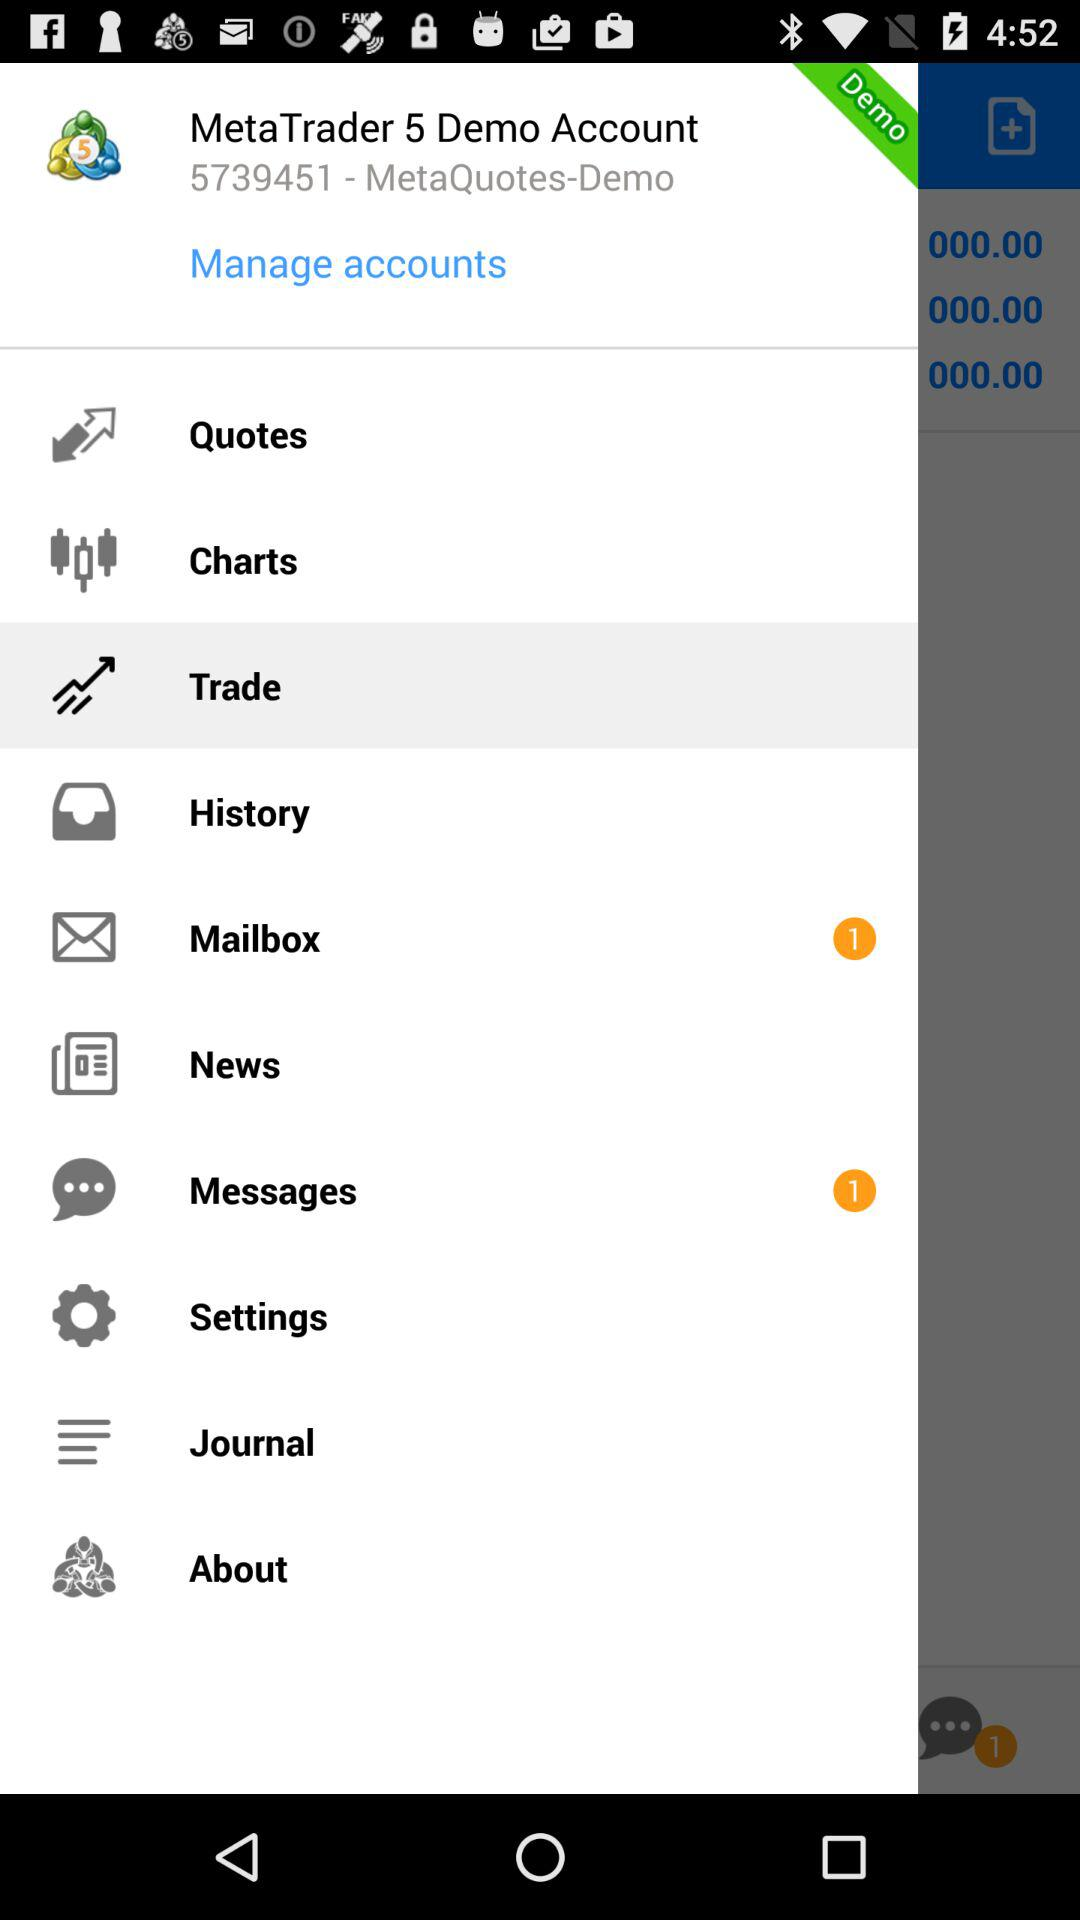What is the number of new messages? The number of new messages is 1. 